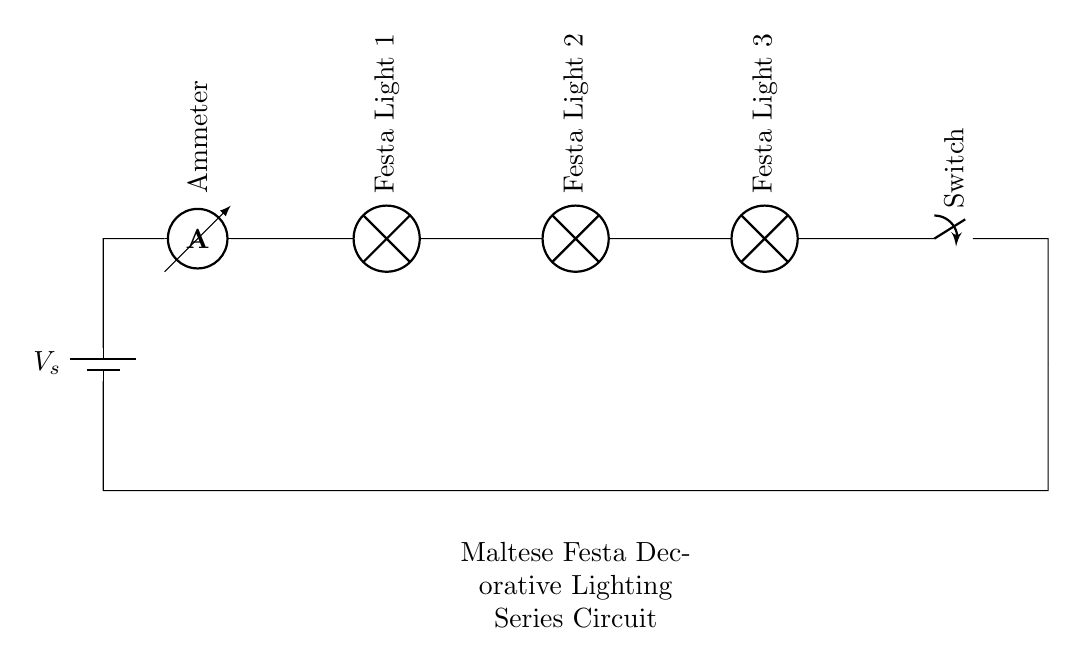What is the source voltage represented in the circuit? The voltage source is represented by the symbol on the left side of the circuit diagram labeled as "Vs." The exact value is not given in the circuit, but it is implied as the voltage supplied to the entire circuit.
Answer: Vs How many festal lights are included in the circuit? The circuit diagram shows three festal lights labeled as "Festa Light 1," "Festa Light 2," and "Festa Light 3." Each is represented as a lamp in series, and their presence is straightforward due to their sequential arrangement along the connecting line.
Answer: Three What type of circuit is depicted in the diagram? The circuit shown is a series circuit as evidenced by the arrangement of components connected in a single path; the current flows through each component one after the other. In a series circuit, if one component fails (like a lamp), the entire circuit would stop functioning.
Answer: Series What is the role of the ammeter in this circuit? The ammeter is used to measure the current flowing through the circuit. It is placed in series with the other components, which allows it to assess the current before it reaches the festal lights and after passing through them. This positioning is essential in measuring the current accurately in a series setup.
Answer: Measure current What would happen if one of the lights in the series circuit burns out? If one of the lights burns out, it would create an open circuit, as series circuits depend on all components being functional; thus, the entire circuit would stop working, and none of the lights would illuminate.
Answer: Entire circuit stops 